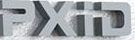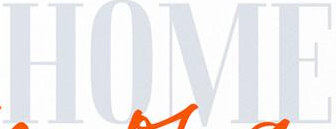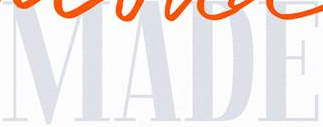What words are shown in these images in order, separated by a semicolon? PXiD; HOME; MADE 